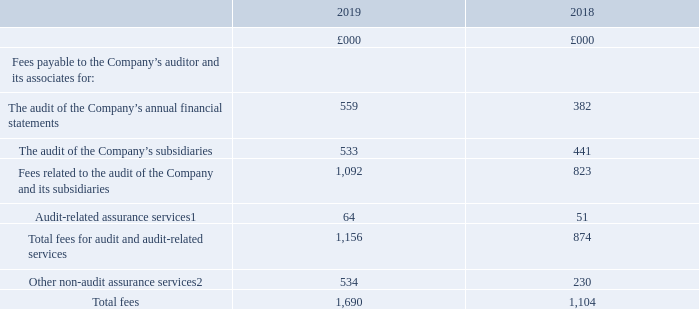8 Auditor’s remuneration
1 Relates to the interim report review of the Group, and interim reviews of certain subsidiary undertakings.
2 2019 other non-audit assurance services relate primarily to reporting accountants’ work associated with the potential equity raise not completed.
The reporting accountants’ work surrounding the potential equity raise not completed includes a working capital report that requires the accountant to have detailed knowledge of the Group. If a firm other than the audit firm were to undertake this work, they would require a significant amount of additional time to become familiar with the Group. Deloitte was therefore chosen to undertake this work as it was considered to be sensible and more efficient both in terms of time and costs.
2018 other non-audit assurance services included £40,000 related to reporting accountants’ work associated with a year end significant change report and £190,000 related to reporting accountants’ work in connection with the Group’s Q3 profit estimate which was required at the time due to Takeover Code rules.
The work surrounding a significant change report and a profit estimate requires the accountant to have detailed knowledge of the Group. If a firm other than the audit firm were to undertake this work, they would require a significant amount of additional time to become familiar with the Group. PwC was therefore chosen to undertake this work as it was considered to be sensible and more efficient both in terms of time and costs.
As for all 2019 and 2018 non-audit work, consideration was given as to whether Deloitte’s (2019) and PwC’s (2018) independence could be affected by undertaking this work. It was concluded by the Audit Committee that this would not be the case.
Fees payable by the Group’s joint ventures in respect of 2019 were £156,000 (Group’s share), all of which relates to audit and audit-related services (2018: £121,000, all of which related to audit and audit-related services).
What were the fees payable by the Group's joint ventures in 2019? £156,000. What were the fees payable related to audit and audit-related services in 2018? £121,000. What is the total fees in 2019?
Answer scale should be: thousand. 1,690. What is the percentage change in the total fees from 2018 to 2019?
Answer scale should be: percent. (1,690-1,104)/1,104
Answer: 53.08. What is the percentage change in the audit-related assurance services from 2018 to 2019?
Answer scale should be: percent. (64-51)/51
Answer: 25.49. What is the percentage of other non-audit assurance services in total fees in 2019?
Answer scale should be: percent. 534/1,690
Answer: 31.6. 